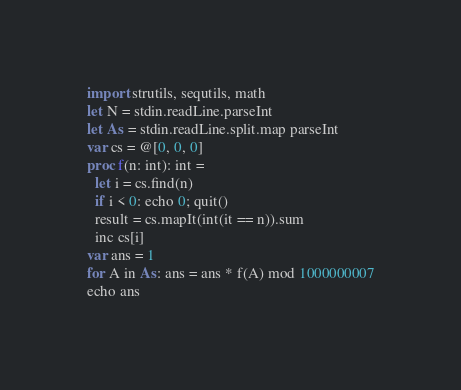Convert code to text. <code><loc_0><loc_0><loc_500><loc_500><_Nim_>import strutils, sequtils, math
let N = stdin.readLine.parseInt
let As = stdin.readLine.split.map parseInt
var cs = @[0, 0, 0]
proc f(n: int): int =
  let i = cs.find(n)
  if i < 0: echo 0; quit()
  result = cs.mapIt(int(it == n)).sum
  inc cs[i]
var ans = 1
for A in As: ans = ans * f(A) mod 1000000007
echo ans</code> 